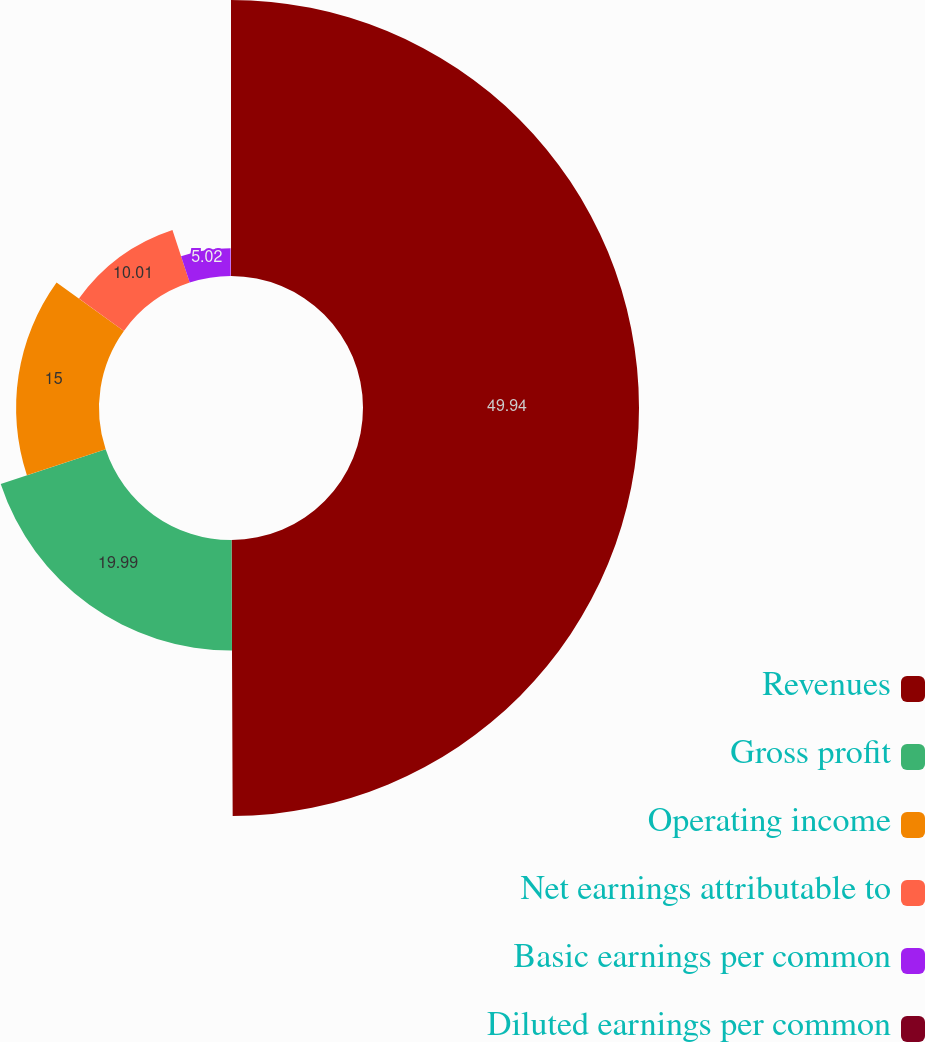Convert chart to OTSL. <chart><loc_0><loc_0><loc_500><loc_500><pie_chart><fcel>Revenues<fcel>Gross profit<fcel>Operating income<fcel>Net earnings attributable to<fcel>Basic earnings per common<fcel>Diluted earnings per common<nl><fcel>49.93%<fcel>19.99%<fcel>15.0%<fcel>10.01%<fcel>5.02%<fcel>0.04%<nl></chart> 